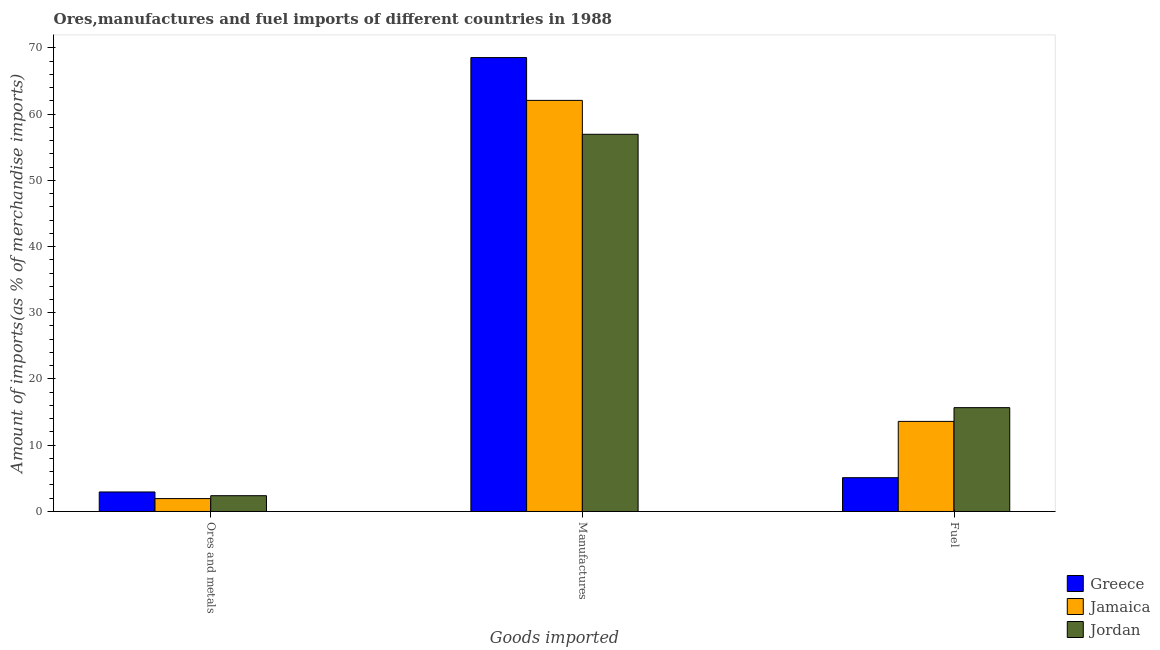How many different coloured bars are there?
Provide a short and direct response. 3. How many bars are there on the 3rd tick from the right?
Ensure brevity in your answer.  3. What is the label of the 3rd group of bars from the left?
Make the answer very short. Fuel. What is the percentage of fuel imports in Greece?
Your response must be concise. 5.1. Across all countries, what is the maximum percentage of ores and metals imports?
Your answer should be very brief. 2.95. Across all countries, what is the minimum percentage of fuel imports?
Offer a terse response. 5.1. In which country was the percentage of manufactures imports maximum?
Provide a short and direct response. Greece. In which country was the percentage of manufactures imports minimum?
Your response must be concise. Jordan. What is the total percentage of manufactures imports in the graph?
Offer a terse response. 187.52. What is the difference between the percentage of ores and metals imports in Jamaica and that in Jordan?
Make the answer very short. -0.44. What is the difference between the percentage of fuel imports in Greece and the percentage of ores and metals imports in Jordan?
Your answer should be compact. 2.72. What is the average percentage of fuel imports per country?
Your response must be concise. 11.46. What is the difference between the percentage of fuel imports and percentage of ores and metals imports in Jamaica?
Make the answer very short. 11.65. In how many countries, is the percentage of manufactures imports greater than 66 %?
Give a very brief answer. 1. What is the ratio of the percentage of ores and metals imports in Jordan to that in Greece?
Offer a terse response. 0.81. Is the percentage of ores and metals imports in Jamaica less than that in Greece?
Ensure brevity in your answer.  Yes. Is the difference between the percentage of fuel imports in Jamaica and Jordan greater than the difference between the percentage of manufactures imports in Jamaica and Jordan?
Ensure brevity in your answer.  No. What is the difference between the highest and the second highest percentage of manufactures imports?
Give a very brief answer. 6.46. What is the difference between the highest and the lowest percentage of ores and metals imports?
Offer a very short reply. 1. In how many countries, is the percentage of fuel imports greater than the average percentage of fuel imports taken over all countries?
Ensure brevity in your answer.  2. What does the 1st bar from the left in Fuel represents?
Make the answer very short. Greece. How many countries are there in the graph?
Keep it short and to the point. 3. What is the difference between two consecutive major ticks on the Y-axis?
Provide a succinct answer. 10. Are the values on the major ticks of Y-axis written in scientific E-notation?
Your answer should be very brief. No. Does the graph contain any zero values?
Offer a terse response. No. Does the graph contain grids?
Your answer should be compact. No. How many legend labels are there?
Your answer should be very brief. 3. How are the legend labels stacked?
Your response must be concise. Vertical. What is the title of the graph?
Your response must be concise. Ores,manufactures and fuel imports of different countries in 1988. What is the label or title of the X-axis?
Provide a short and direct response. Goods imported. What is the label or title of the Y-axis?
Keep it short and to the point. Amount of imports(as % of merchandise imports). What is the Amount of imports(as % of merchandise imports) of Greece in Ores and metals?
Provide a succinct answer. 2.95. What is the Amount of imports(as % of merchandise imports) of Jamaica in Ores and metals?
Give a very brief answer. 1.95. What is the Amount of imports(as % of merchandise imports) of Jordan in Ores and metals?
Provide a short and direct response. 2.38. What is the Amount of imports(as % of merchandise imports) in Greece in Manufactures?
Keep it short and to the point. 68.52. What is the Amount of imports(as % of merchandise imports) in Jamaica in Manufactures?
Offer a very short reply. 62.06. What is the Amount of imports(as % of merchandise imports) in Jordan in Manufactures?
Your answer should be compact. 56.94. What is the Amount of imports(as % of merchandise imports) of Greece in Fuel?
Your answer should be very brief. 5.1. What is the Amount of imports(as % of merchandise imports) of Jamaica in Fuel?
Your answer should be compact. 13.6. What is the Amount of imports(as % of merchandise imports) in Jordan in Fuel?
Provide a succinct answer. 15.68. Across all Goods imported, what is the maximum Amount of imports(as % of merchandise imports) of Greece?
Your answer should be very brief. 68.52. Across all Goods imported, what is the maximum Amount of imports(as % of merchandise imports) of Jamaica?
Offer a terse response. 62.06. Across all Goods imported, what is the maximum Amount of imports(as % of merchandise imports) of Jordan?
Offer a very short reply. 56.94. Across all Goods imported, what is the minimum Amount of imports(as % of merchandise imports) in Greece?
Your response must be concise. 2.95. Across all Goods imported, what is the minimum Amount of imports(as % of merchandise imports) in Jamaica?
Keep it short and to the point. 1.95. Across all Goods imported, what is the minimum Amount of imports(as % of merchandise imports) of Jordan?
Ensure brevity in your answer.  2.38. What is the total Amount of imports(as % of merchandise imports) in Greece in the graph?
Make the answer very short. 76.57. What is the total Amount of imports(as % of merchandise imports) in Jamaica in the graph?
Keep it short and to the point. 77.6. What is the total Amount of imports(as % of merchandise imports) in Jordan in the graph?
Make the answer very short. 75. What is the difference between the Amount of imports(as % of merchandise imports) of Greece in Ores and metals and that in Manufactures?
Give a very brief answer. -65.57. What is the difference between the Amount of imports(as % of merchandise imports) of Jamaica in Ores and metals and that in Manufactures?
Keep it short and to the point. -60.11. What is the difference between the Amount of imports(as % of merchandise imports) in Jordan in Ores and metals and that in Manufactures?
Your answer should be very brief. -54.56. What is the difference between the Amount of imports(as % of merchandise imports) in Greece in Ores and metals and that in Fuel?
Provide a succinct answer. -2.16. What is the difference between the Amount of imports(as % of merchandise imports) in Jamaica in Ores and metals and that in Fuel?
Give a very brief answer. -11.65. What is the difference between the Amount of imports(as % of merchandise imports) in Jordan in Ores and metals and that in Fuel?
Ensure brevity in your answer.  -13.29. What is the difference between the Amount of imports(as % of merchandise imports) in Greece in Manufactures and that in Fuel?
Your answer should be compact. 63.42. What is the difference between the Amount of imports(as % of merchandise imports) of Jamaica in Manufactures and that in Fuel?
Offer a terse response. 48.46. What is the difference between the Amount of imports(as % of merchandise imports) in Jordan in Manufactures and that in Fuel?
Offer a terse response. 41.26. What is the difference between the Amount of imports(as % of merchandise imports) of Greece in Ores and metals and the Amount of imports(as % of merchandise imports) of Jamaica in Manufactures?
Provide a succinct answer. -59.11. What is the difference between the Amount of imports(as % of merchandise imports) of Greece in Ores and metals and the Amount of imports(as % of merchandise imports) of Jordan in Manufactures?
Your answer should be very brief. -53.99. What is the difference between the Amount of imports(as % of merchandise imports) in Jamaica in Ores and metals and the Amount of imports(as % of merchandise imports) in Jordan in Manufactures?
Offer a terse response. -54.99. What is the difference between the Amount of imports(as % of merchandise imports) in Greece in Ores and metals and the Amount of imports(as % of merchandise imports) in Jamaica in Fuel?
Provide a short and direct response. -10.65. What is the difference between the Amount of imports(as % of merchandise imports) of Greece in Ores and metals and the Amount of imports(as % of merchandise imports) of Jordan in Fuel?
Your answer should be very brief. -12.73. What is the difference between the Amount of imports(as % of merchandise imports) of Jamaica in Ores and metals and the Amount of imports(as % of merchandise imports) of Jordan in Fuel?
Your answer should be compact. -13.73. What is the difference between the Amount of imports(as % of merchandise imports) in Greece in Manufactures and the Amount of imports(as % of merchandise imports) in Jamaica in Fuel?
Give a very brief answer. 54.92. What is the difference between the Amount of imports(as % of merchandise imports) in Greece in Manufactures and the Amount of imports(as % of merchandise imports) in Jordan in Fuel?
Ensure brevity in your answer.  52.85. What is the difference between the Amount of imports(as % of merchandise imports) of Jamaica in Manufactures and the Amount of imports(as % of merchandise imports) of Jordan in Fuel?
Make the answer very short. 46.38. What is the average Amount of imports(as % of merchandise imports) of Greece per Goods imported?
Provide a succinct answer. 25.52. What is the average Amount of imports(as % of merchandise imports) of Jamaica per Goods imported?
Keep it short and to the point. 25.87. What is the average Amount of imports(as % of merchandise imports) of Jordan per Goods imported?
Your response must be concise. 25. What is the difference between the Amount of imports(as % of merchandise imports) of Greece and Amount of imports(as % of merchandise imports) of Jordan in Ores and metals?
Ensure brevity in your answer.  0.56. What is the difference between the Amount of imports(as % of merchandise imports) in Jamaica and Amount of imports(as % of merchandise imports) in Jordan in Ores and metals?
Your answer should be compact. -0.44. What is the difference between the Amount of imports(as % of merchandise imports) of Greece and Amount of imports(as % of merchandise imports) of Jamaica in Manufactures?
Provide a succinct answer. 6.46. What is the difference between the Amount of imports(as % of merchandise imports) in Greece and Amount of imports(as % of merchandise imports) in Jordan in Manufactures?
Keep it short and to the point. 11.58. What is the difference between the Amount of imports(as % of merchandise imports) in Jamaica and Amount of imports(as % of merchandise imports) in Jordan in Manufactures?
Provide a short and direct response. 5.12. What is the difference between the Amount of imports(as % of merchandise imports) of Greece and Amount of imports(as % of merchandise imports) of Jamaica in Fuel?
Make the answer very short. -8.5. What is the difference between the Amount of imports(as % of merchandise imports) in Greece and Amount of imports(as % of merchandise imports) in Jordan in Fuel?
Keep it short and to the point. -10.57. What is the difference between the Amount of imports(as % of merchandise imports) of Jamaica and Amount of imports(as % of merchandise imports) of Jordan in Fuel?
Provide a short and direct response. -2.08. What is the ratio of the Amount of imports(as % of merchandise imports) in Greece in Ores and metals to that in Manufactures?
Give a very brief answer. 0.04. What is the ratio of the Amount of imports(as % of merchandise imports) of Jamaica in Ores and metals to that in Manufactures?
Offer a terse response. 0.03. What is the ratio of the Amount of imports(as % of merchandise imports) in Jordan in Ores and metals to that in Manufactures?
Your answer should be compact. 0.04. What is the ratio of the Amount of imports(as % of merchandise imports) in Greece in Ores and metals to that in Fuel?
Your answer should be very brief. 0.58. What is the ratio of the Amount of imports(as % of merchandise imports) in Jamaica in Ores and metals to that in Fuel?
Offer a very short reply. 0.14. What is the ratio of the Amount of imports(as % of merchandise imports) of Jordan in Ores and metals to that in Fuel?
Make the answer very short. 0.15. What is the ratio of the Amount of imports(as % of merchandise imports) of Greece in Manufactures to that in Fuel?
Your response must be concise. 13.43. What is the ratio of the Amount of imports(as % of merchandise imports) of Jamaica in Manufactures to that in Fuel?
Provide a succinct answer. 4.56. What is the ratio of the Amount of imports(as % of merchandise imports) of Jordan in Manufactures to that in Fuel?
Your response must be concise. 3.63. What is the difference between the highest and the second highest Amount of imports(as % of merchandise imports) in Greece?
Give a very brief answer. 63.42. What is the difference between the highest and the second highest Amount of imports(as % of merchandise imports) in Jamaica?
Provide a succinct answer. 48.46. What is the difference between the highest and the second highest Amount of imports(as % of merchandise imports) in Jordan?
Provide a succinct answer. 41.26. What is the difference between the highest and the lowest Amount of imports(as % of merchandise imports) of Greece?
Your answer should be compact. 65.57. What is the difference between the highest and the lowest Amount of imports(as % of merchandise imports) in Jamaica?
Keep it short and to the point. 60.11. What is the difference between the highest and the lowest Amount of imports(as % of merchandise imports) of Jordan?
Your answer should be compact. 54.56. 